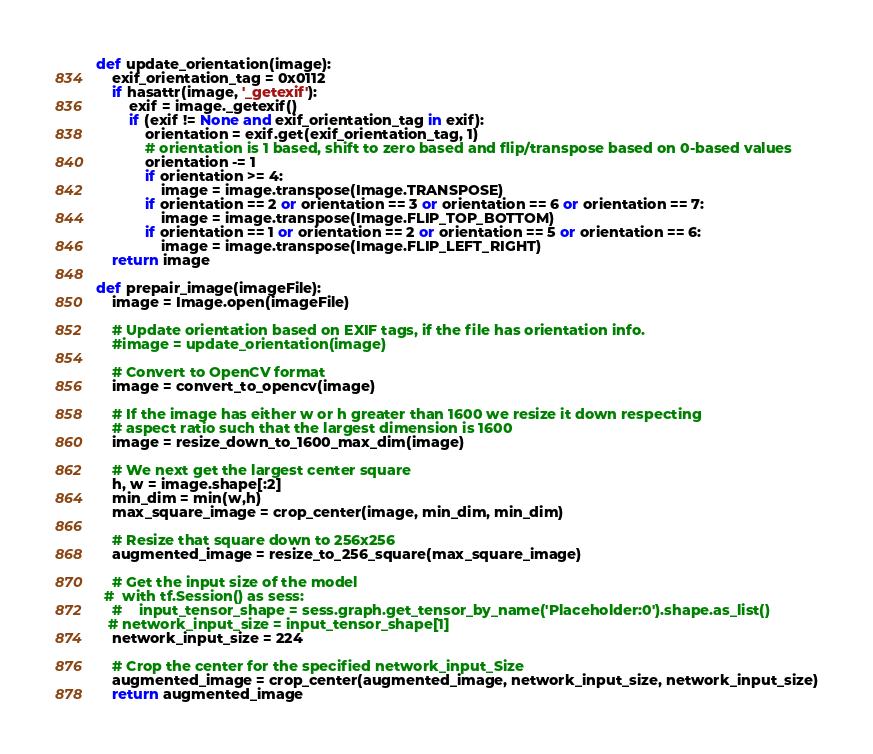Convert code to text. <code><loc_0><loc_0><loc_500><loc_500><_Python_>
def update_orientation(image):
    exif_orientation_tag = 0x0112
    if hasattr(image, '_getexif'):
        exif = image._getexif()
        if (exif != None and exif_orientation_tag in exif):
            orientation = exif.get(exif_orientation_tag, 1)
            # orientation is 1 based, shift to zero based and flip/transpose based on 0-based values
            orientation -= 1
            if orientation >= 4:
                image = image.transpose(Image.TRANSPOSE)
            if orientation == 2 or orientation == 3 or orientation == 6 or orientation == 7:
                image = image.transpose(Image.FLIP_TOP_BOTTOM)
            if orientation == 1 or orientation == 2 or orientation == 5 or orientation == 6:
                image = image.transpose(Image.FLIP_LEFT_RIGHT)
    return image

def prepair_image(imageFile):
    image = Image.open(imageFile)

    # Update orientation based on EXIF tags, if the file has orientation info.
    #image = update_orientation(image)

    # Convert to OpenCV format
    image = convert_to_opencv(image)

    # If the image has either w or h greater than 1600 we resize it down respecting
    # aspect ratio such that the largest dimension is 1600
    image = resize_down_to_1600_max_dim(image)

    # We next get the largest center square
    h, w = image.shape[:2]
    min_dim = min(w,h)
    max_square_image = crop_center(image, min_dim, min_dim)

    # Resize that square down to 256x256
    augmented_image = resize_to_256_square(max_square_image)

    # Get the input size of the model
  #  with tf.Session() as sess:
    #    input_tensor_shape = sess.graph.get_tensor_by_name('Placeholder:0').shape.as_list()
   # network_input_size = input_tensor_shape[1]
    network_input_size = 224
    
    # Crop the center for the specified network_input_Size
    augmented_image = crop_center(augmented_image, network_input_size, network_input_size)
    return augmented_image
</code> 